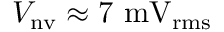Convert formula to latex. <formula><loc_0><loc_0><loc_500><loc_500>V _ { n v } \approx 7 m V _ { r m s }</formula> 